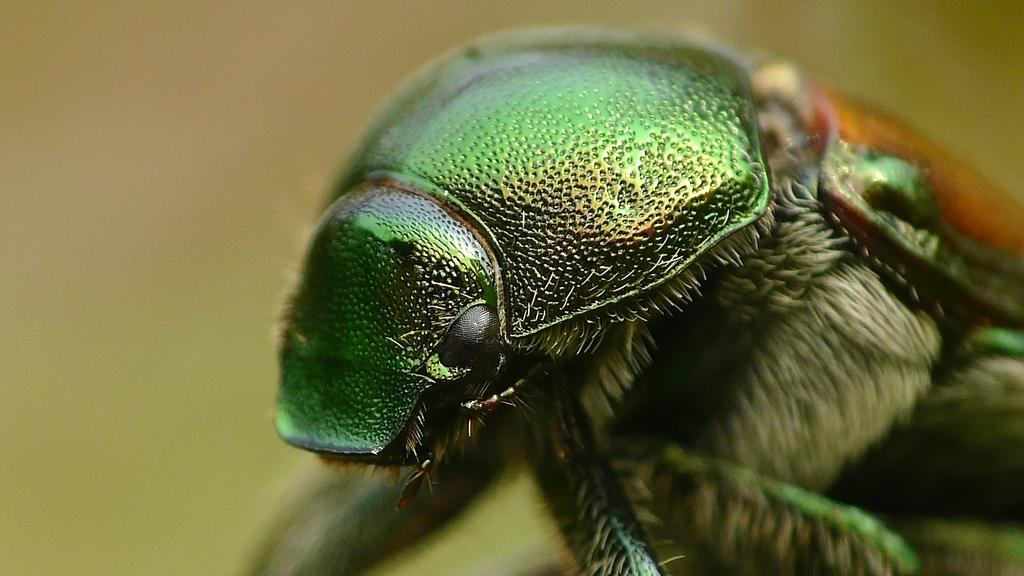What type of creature can be seen in the image? There is an insect in the image. Can you describe the background of the image? The background of the image is blurred. Is there a cactus in the image? There is no mention of a cactus in the provided facts, so it cannot be determined if one is present in the image. 